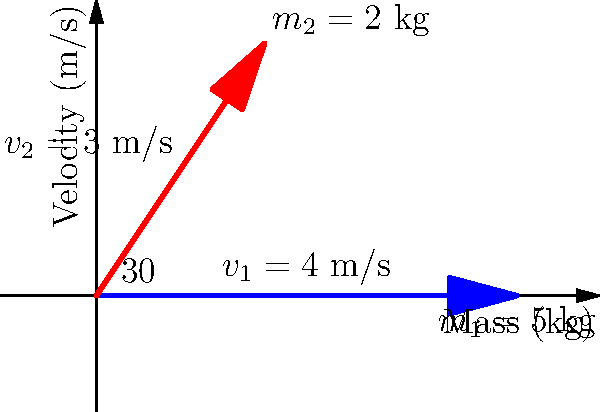In a collision investigation, you're analyzing the impact between two objects. Object 1 with mass $m_1 = 5$ kg is moving horizontally at $v_1 = 4$ m/s. It collides with Object 2, mass $m_2 = 2$ kg, moving at $v_2 = 3$ m/s at a 30° angle above the horizontal. Assuming a perfectly inelastic collision, what is the velocity of the combined objects immediately after impact? To solve this problem, we'll use conservation of momentum in both x and y directions:

1) Convert velocities to x and y components:
   Object 1: $v_{1x} = 4$ m/s, $v_{1y} = 0$ m/s
   Object 2: $v_{2x} = 3 \cos(30°) = 2.60$ m/s, $v_{2y} = 3 \sin(30°) = 1.50$ m/s

2) Apply conservation of momentum in x-direction:
   $$(m_1v_{1x} + m_2v_{2x} = (m_1 + m_2)v_x)$$
   $$(5 \cdot 4 + 2 \cdot 2.60 = 7v_x)$$
   $$25.2 = 7v_x$$
   $$v_x = 3.60$$ m/s

3) Apply conservation of momentum in y-direction:
   $$(m_1v_{1y} + m_2v_{2y} = (m_1 + m_2)v_y)$$
   $$(5 \cdot 0 + 2 \cdot 1.50 = 7v_y)$$
   $$3 = 7v_y$$
   $$v_y = 0.429$$ m/s

4) Calculate the resultant velocity:
   $$v = \sqrt{v_x^2 + v_y^2} = \sqrt{3.60^2 + 0.429^2} = 3.63$$ m/s

5) Calculate the angle with respect to the horizontal:
   $$\theta = \tan^{-1}\left(\frac{v_y}{v_x}\right) = \tan^{-1}\left(\frac{0.429}{3.60}\right) = 6.79°$$

Therefore, the combined objects move at 3.63 m/s at an angle of 6.79° above the horizontal immediately after the collision.
Answer: 3.63 m/s at 6.79° above horizontal 